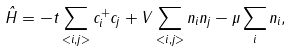Convert formula to latex. <formula><loc_0><loc_0><loc_500><loc_500>\hat { H } = - t \sum _ { < i , j > } c ^ { + } _ { i } c _ { j } + V \sum _ { < i , j > } n _ { i } n _ { j } - \mu \sum _ { i } n _ { i } ,</formula> 